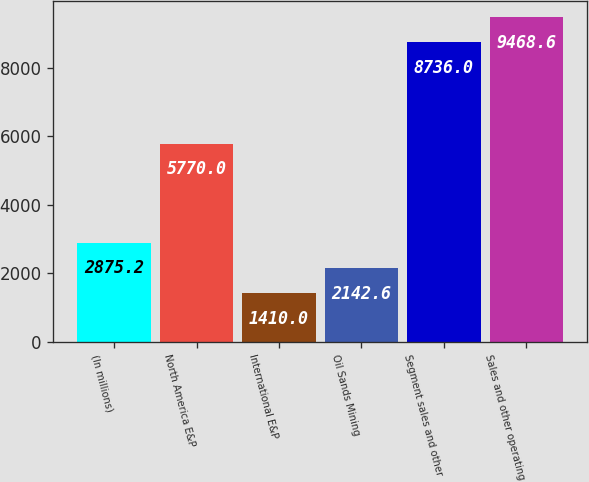Convert chart. <chart><loc_0><loc_0><loc_500><loc_500><bar_chart><fcel>(In millions)<fcel>North America E&P<fcel>International E&P<fcel>Oil Sands Mining<fcel>Segment sales and other<fcel>Sales and other operating<nl><fcel>2875.2<fcel>5770<fcel>1410<fcel>2142.6<fcel>8736<fcel>9468.6<nl></chart> 